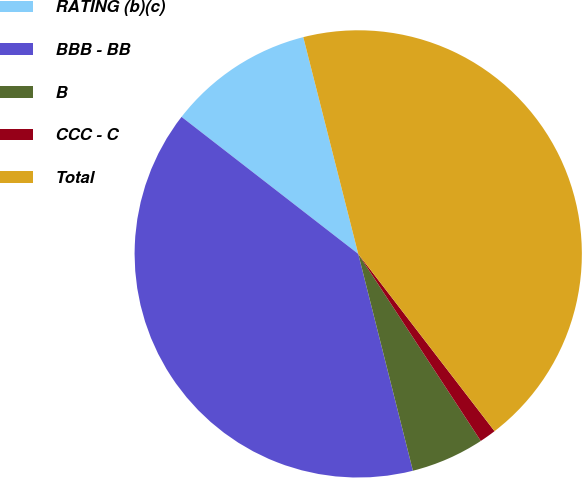<chart> <loc_0><loc_0><loc_500><loc_500><pie_chart><fcel>RATING (b)(c)<fcel>BBB - BB<fcel>B<fcel>CCC - C<fcel>Total<nl><fcel>10.55%<fcel>39.43%<fcel>5.3%<fcel>1.2%<fcel>43.52%<nl></chart> 